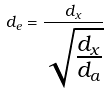Convert formula to latex. <formula><loc_0><loc_0><loc_500><loc_500>d _ { e } = \frac { d _ { x } } { \sqrt { \frac { d _ { x } } { d _ { a } } } }</formula> 